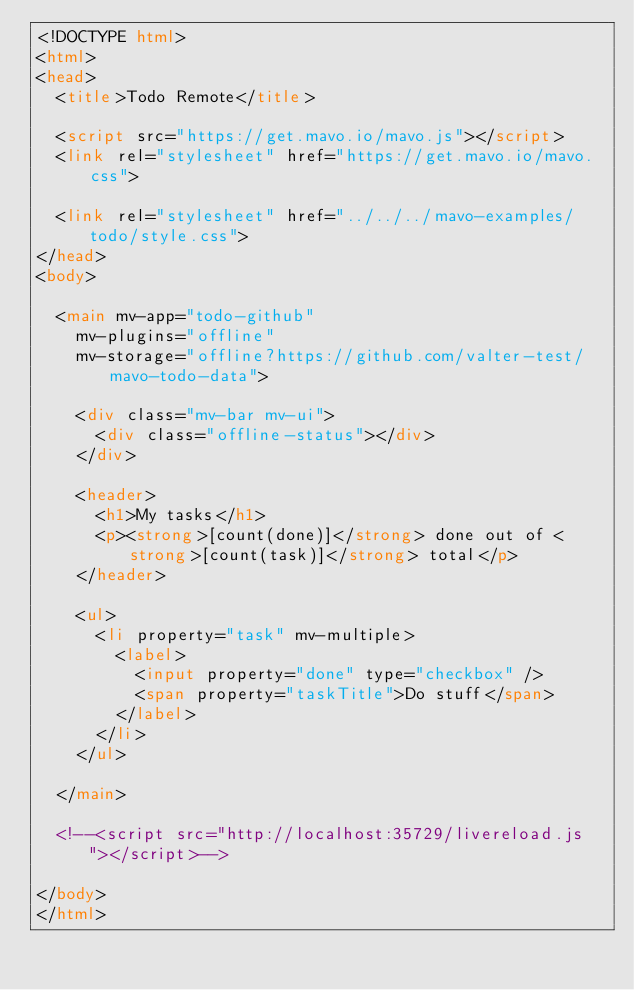Convert code to text. <code><loc_0><loc_0><loc_500><loc_500><_HTML_><!DOCTYPE html>
<html>
<head>
  <title>Todo Remote</title>

  <script src="https://get.mavo.io/mavo.js"></script>
  <link rel="stylesheet" href="https://get.mavo.io/mavo.css">

  <link rel="stylesheet" href="../../../mavo-examples/todo/style.css">
</head>
<body>

  <main mv-app="todo-github"
    mv-plugins="offline"
    mv-storage="offline?https://github.com/valter-test/mavo-todo-data">

    <div class="mv-bar mv-ui">
      <div class="offline-status"></div>
    </div>

    <header>
      <h1>My tasks</h1>
      <p><strong>[count(done)]</strong> done out of <strong>[count(task)]</strong> total</p>
    </header>

    <ul>
      <li property="task" mv-multiple>
        <label>
          <input property="done" type="checkbox" />
          <span property="taskTitle">Do stuff</span>
        </label>
      </li>
    </ul>

  </main>

  <!--<script src="http://localhost:35729/livereload.js"></script>-->

</body>
</html>
</code> 